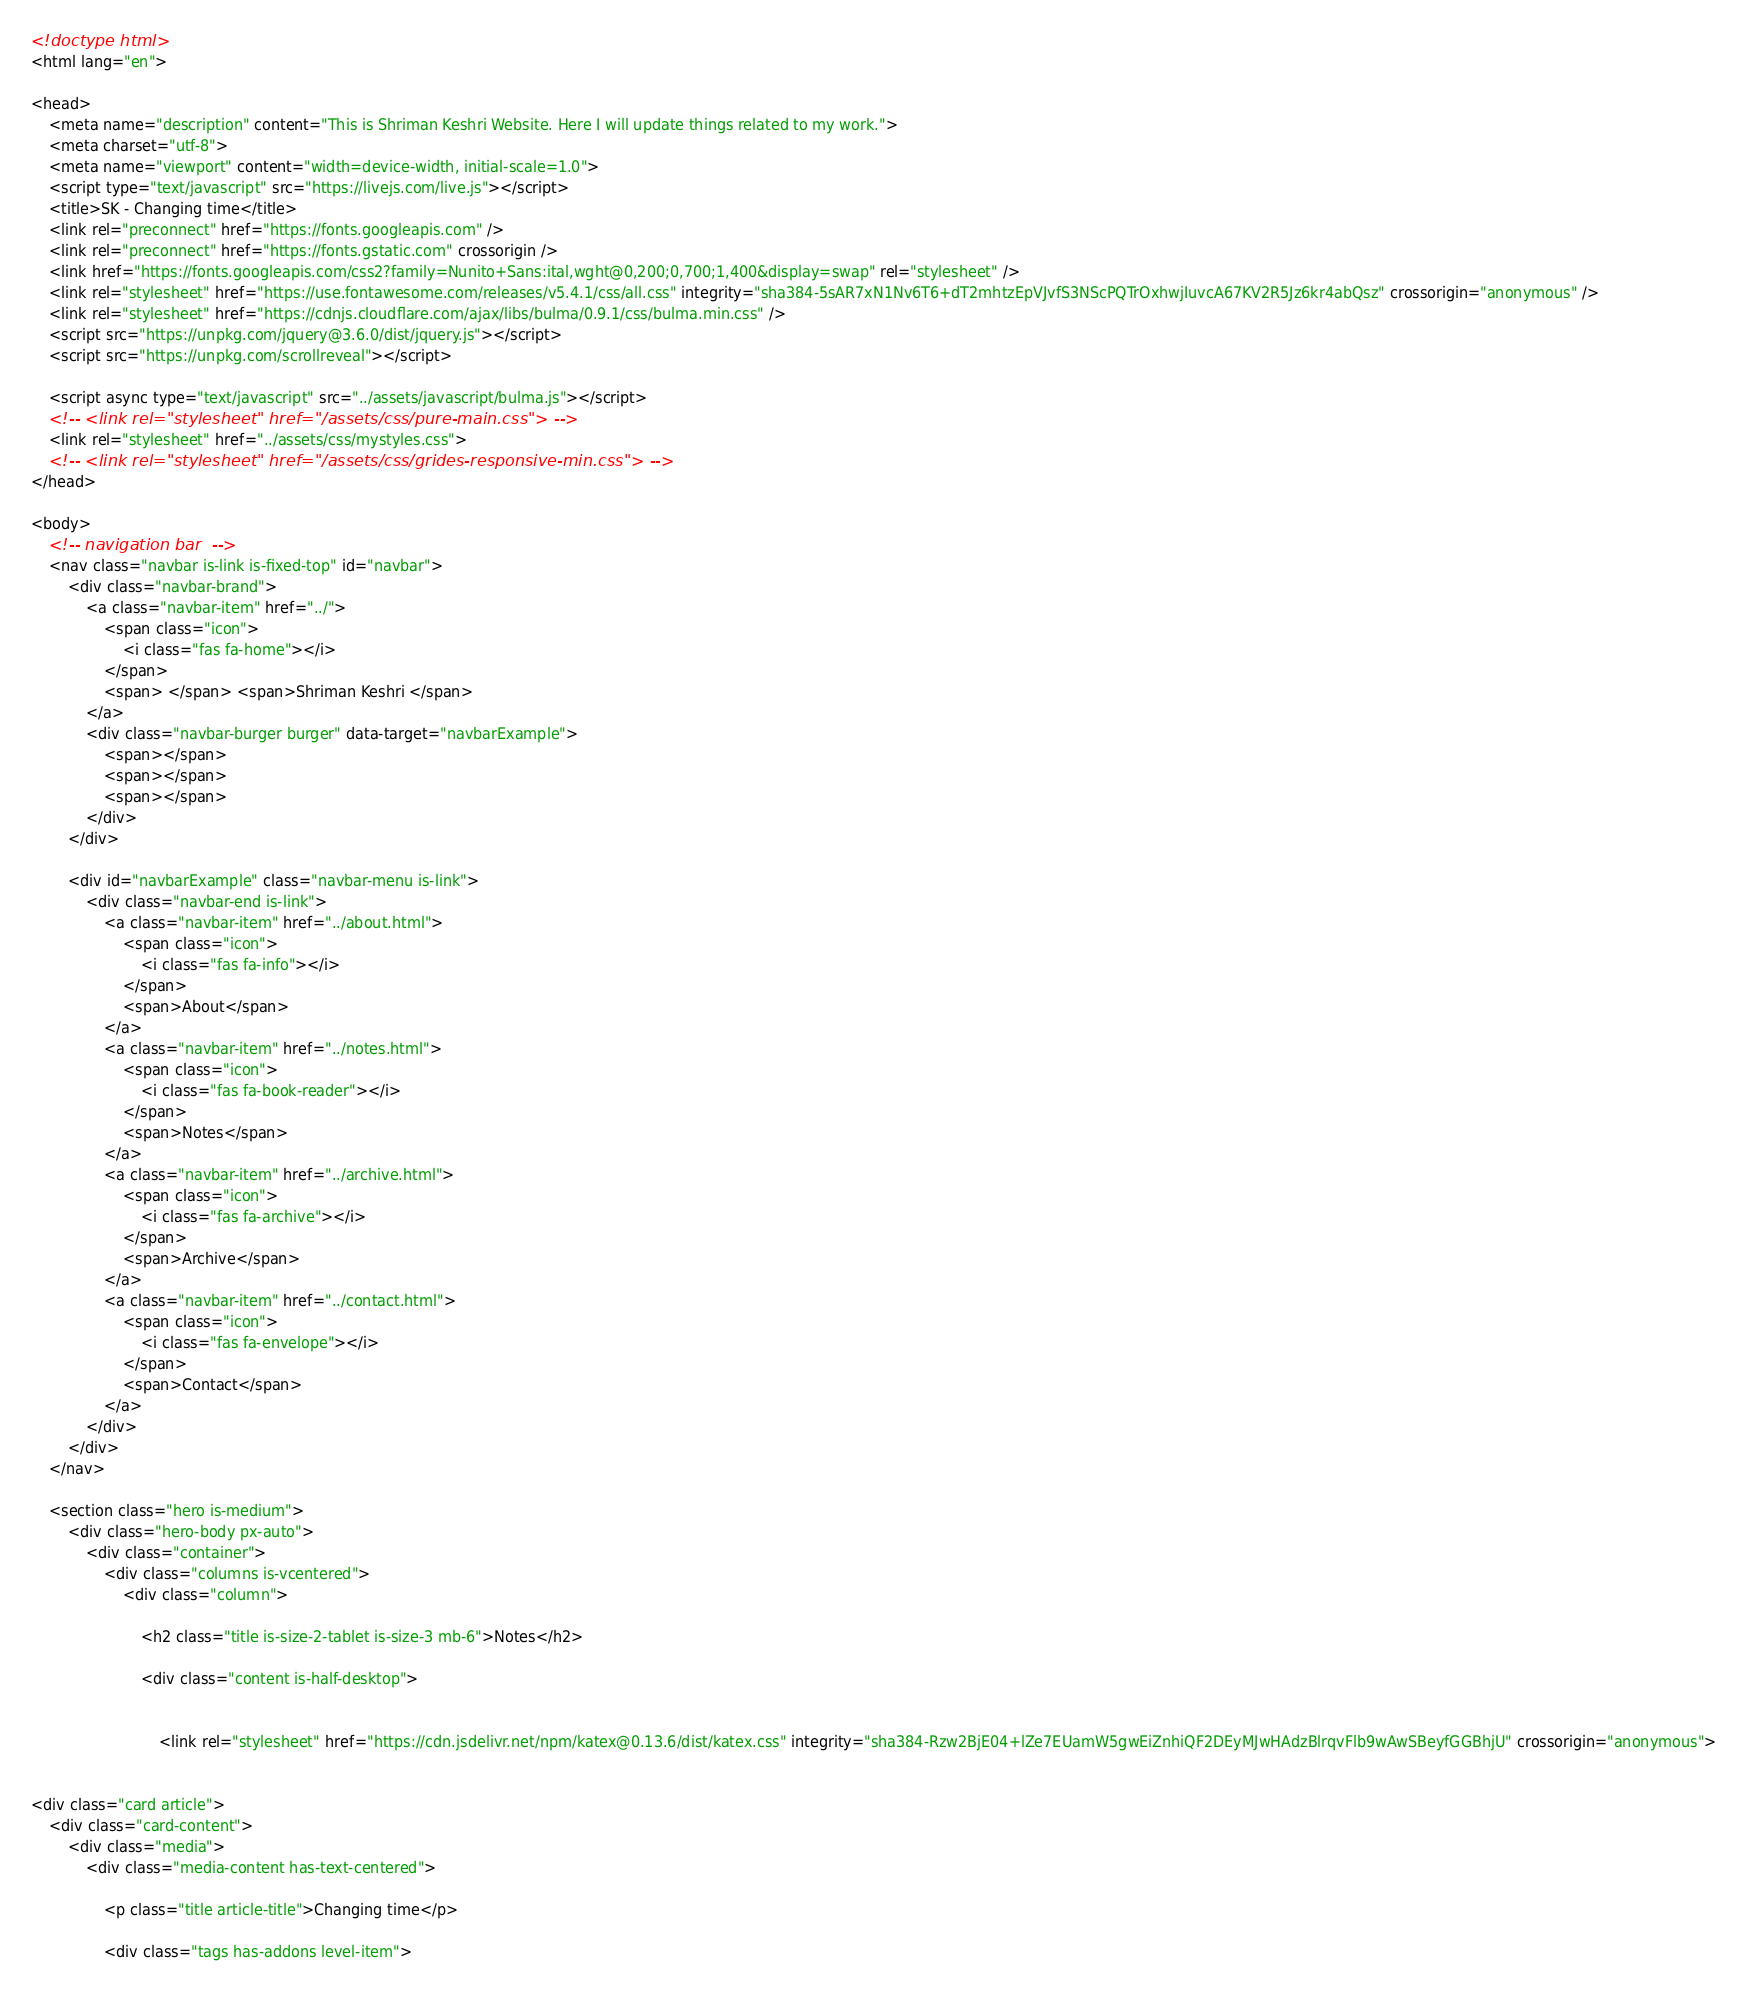Convert code to text. <code><loc_0><loc_0><loc_500><loc_500><_HTML_><!doctype html>
<html lang="en">

<head>
    <meta name="description" content="This is Shriman Keshri Website. Here I will update things related to my work.">
    <meta charset="utf-8">
    <meta name="viewport" content="width=device-width, initial-scale=1.0">
    <script type="text/javascript" src="https://livejs.com/live.js"></script>
    <title>SK - Changing time</title>
    <link rel="preconnect" href="https://fonts.googleapis.com" />
    <link rel="preconnect" href="https://fonts.gstatic.com" crossorigin />
    <link href="https://fonts.googleapis.com/css2?family=Nunito+Sans:ital,wght@0,200;0,700;1,400&display=swap" rel="stylesheet" />
    <link rel="stylesheet" href="https://use.fontawesome.com/releases/v5.4.1/css/all.css" integrity="sha384-5sAR7xN1Nv6T6+dT2mhtzEpVJvfS3NScPQTrOxhwjIuvcA67KV2R5Jz6kr4abQsz" crossorigin="anonymous" />
    <link rel="stylesheet" href="https://cdnjs.cloudflare.com/ajax/libs/bulma/0.9.1/css/bulma.min.css" />
    <script src="https://unpkg.com/jquery@3.6.0/dist/jquery.js"></script>
    <script src="https://unpkg.com/scrollreveal"></script>

    <script async type="text/javascript" src="../assets/javascript/bulma.js"></script>
    <!-- <link rel="stylesheet" href="/assets/css/pure-main.css"> -->
    <link rel="stylesheet" href="../assets/css/mystyles.css">
    <!-- <link rel="stylesheet" href="/assets/css/grides-responsive-min.css"> -->
</head>

<body>
    <!-- navigation bar  -->
    <nav class="navbar is-link is-fixed-top" id="navbar">
        <div class="navbar-brand">
            <a class="navbar-item" href="../">
                <span class="icon">
                    <i class="fas fa-home"></i>
                </span>
                <span> </span> <span>Shriman Keshri </span>
            </a>
            <div class="navbar-burger burger" data-target="navbarExample">
                <span></span>
                <span></span>
                <span></span>
            </div>
        </div>

        <div id="navbarExample" class="navbar-menu is-link">
            <div class="navbar-end is-link">
                <a class="navbar-item" href="../about.html">
                    <span class="icon">
                        <i class="fas fa-info"></i>
                    </span>
                    <span>About</span>
                </a>
                <a class="navbar-item" href="../notes.html">
                    <span class="icon">
                        <i class="fas fa-book-reader"></i>
                    </span>
                    <span>Notes</span>
                </a>
                <a class="navbar-item" href="../archive.html">
                    <span class="icon">
                        <i class="fas fa-archive"></i>
                    </span>
                    <span>Archive</span>
                </a>
                <a class="navbar-item" href="../contact.html">
                    <span class="icon">
                        <i class="fas fa-envelope"></i>
                    </span>
                    <span>Contact</span>
                </a>
            </div>
        </div>
    </nav>

    <section class="hero is-medium">
        <div class="hero-body px-auto">
            <div class="container">
                <div class="columns is-vcentered">
                    <div class="column">

                        <h2 class="title is-size-2-tablet is-size-3 mb-6">Notes</h2>

                        <div class="content is-half-desktop">


                            <link rel="stylesheet" href="https://cdn.jsdelivr.net/npm/katex@0.13.6/dist/katex.css" integrity="sha384-Rzw2BjE04+lZe7EUamW5gwEiZnhiQF2DEyMJwHAdzBlrqvFlb9wAwSBeyfGGBhjU" crossorigin="anonymous">


<div class="card article">
    <div class="card-content">
        <div class="media">
            <div class="media-content has-text-centered">
                
                <p class="title article-title">Changing time</p>
                
                <div class="tags has-addons level-item">
                    </code> 